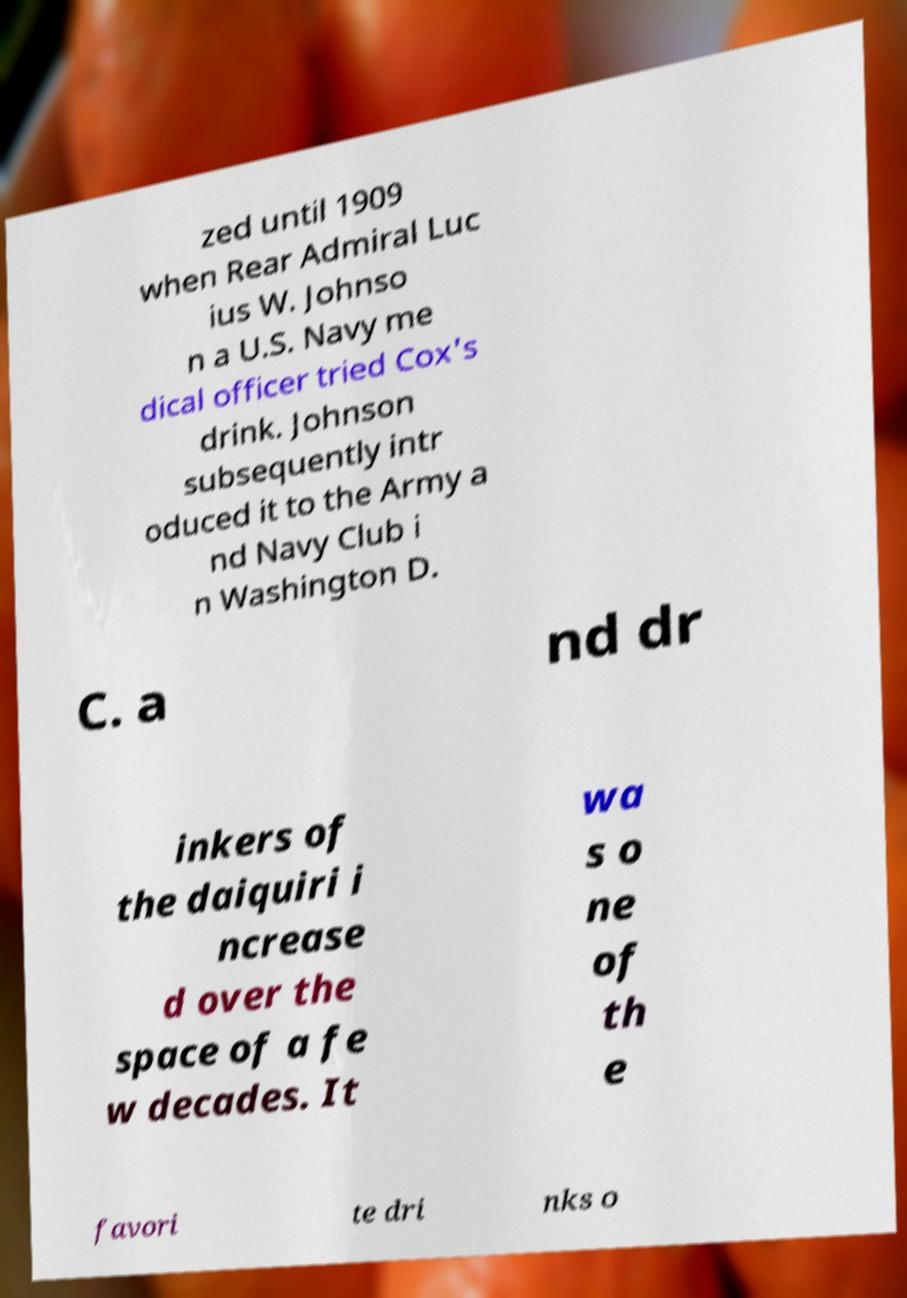Can you accurately transcribe the text from the provided image for me? zed until 1909 when Rear Admiral Luc ius W. Johnso n a U.S. Navy me dical officer tried Cox's drink. Johnson subsequently intr oduced it to the Army a nd Navy Club i n Washington D. C. a nd dr inkers of the daiquiri i ncrease d over the space of a fe w decades. It wa s o ne of th e favori te dri nks o 